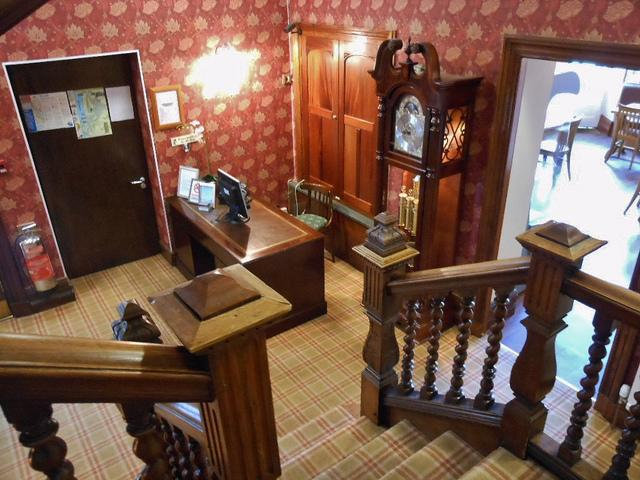What is attached to the brown door? Please explain your reasoning. papers. There are sheets of paper on the door. 